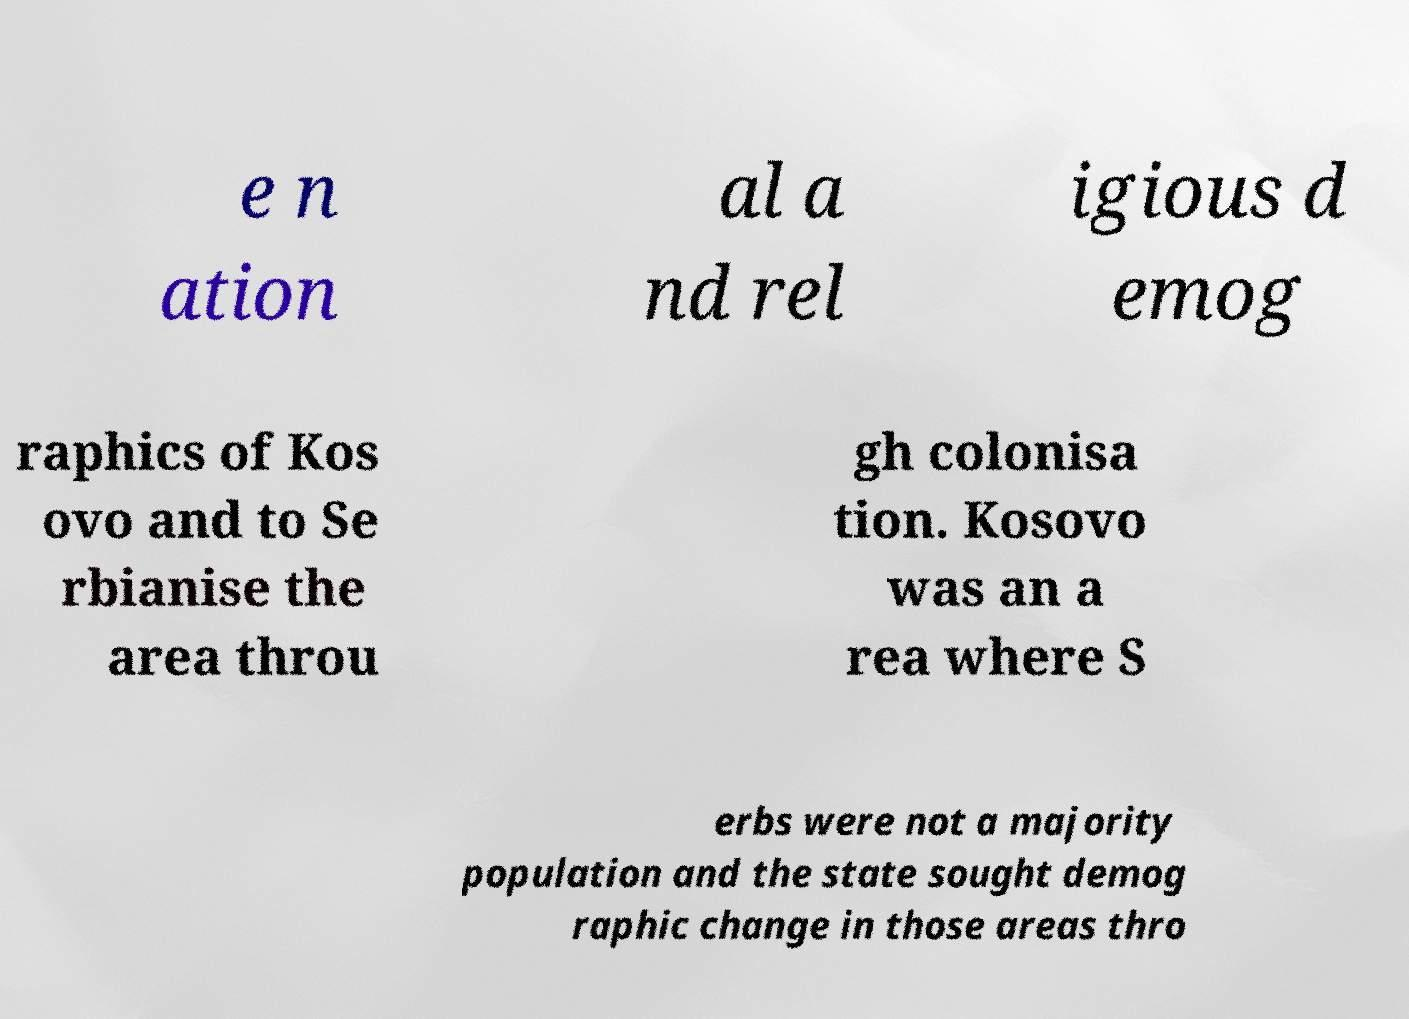There's text embedded in this image that I need extracted. Can you transcribe it verbatim? e n ation al a nd rel igious d emog raphics of Kos ovo and to Se rbianise the area throu gh colonisa tion. Kosovo was an a rea where S erbs were not a majority population and the state sought demog raphic change in those areas thro 